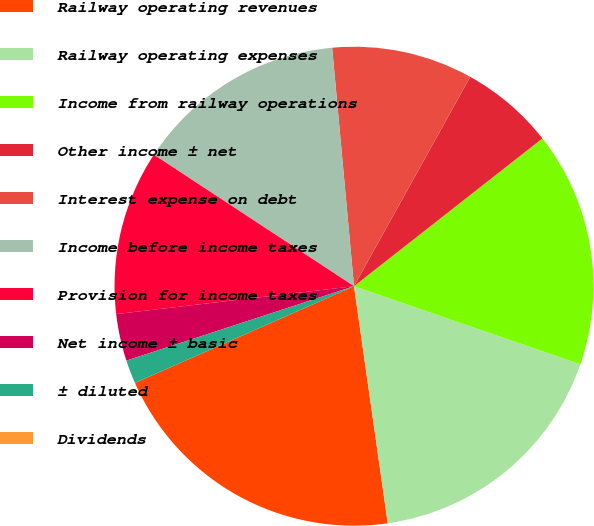Convert chart to OTSL. <chart><loc_0><loc_0><loc_500><loc_500><pie_chart><fcel>Railway operating revenues<fcel>Railway operating expenses<fcel>Income from railway operations<fcel>Other income ± net<fcel>Interest expense on debt<fcel>Income before income taxes<fcel>Provision for income taxes<fcel>Net income ± basic<fcel>± diluted<fcel>Dividends<nl><fcel>20.63%<fcel>17.46%<fcel>15.87%<fcel>6.35%<fcel>9.52%<fcel>14.29%<fcel>11.11%<fcel>3.17%<fcel>1.59%<fcel>0.0%<nl></chart> 